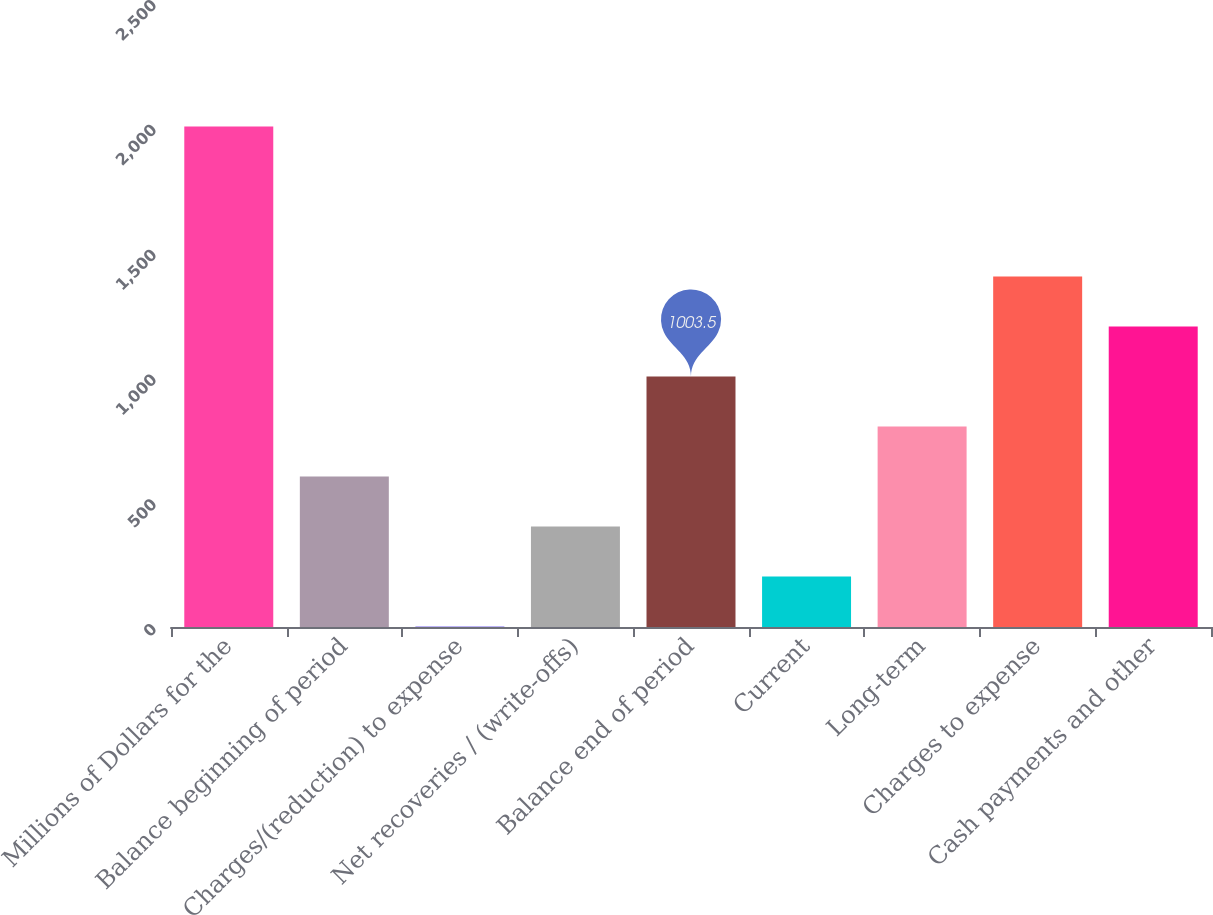<chart> <loc_0><loc_0><loc_500><loc_500><bar_chart><fcel>Millions of Dollars for the<fcel>Balance beginning of period<fcel>Charges/(reduction) to expense<fcel>Net recoveries / (write-offs)<fcel>Balance end of period<fcel>Current<fcel>Long-term<fcel>Charges to expense<fcel>Cash payments and other<nl><fcel>2005<fcel>602.9<fcel>2<fcel>402.6<fcel>1003.5<fcel>202.3<fcel>803.2<fcel>1404.1<fcel>1203.8<nl></chart> 